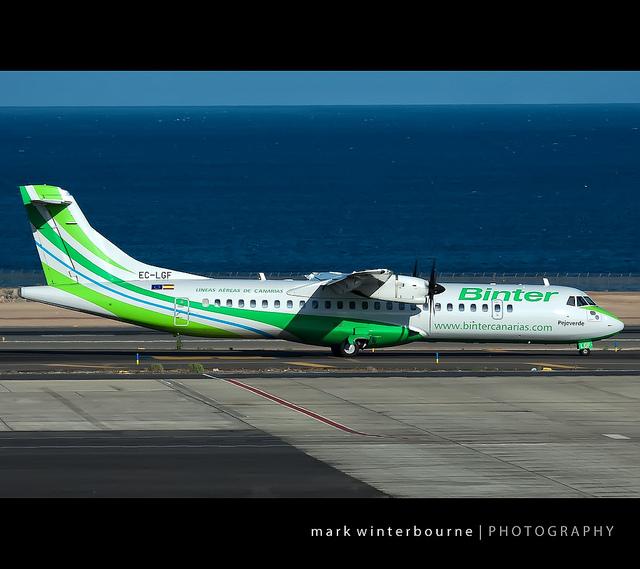What kind of vehicle is this?
Short answer required. Airplane. What is company printed on the plane?
Give a very brief answer. Binter. Did this plan land on an aircraft carrier?
Answer briefly. Yes. 